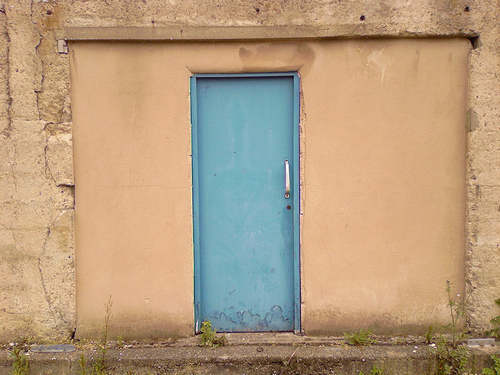<image>
Is there a door next to the wall? No. The door is not positioned next to the wall. They are located in different areas of the scene. 